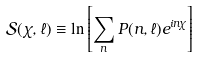Convert formula to latex. <formula><loc_0><loc_0><loc_500><loc_500>\mathcal { S } ( \chi , \ell ) \equiv \ln \left [ \sum _ { n } P ( n , \ell ) e ^ { i n \chi } \right ]</formula> 